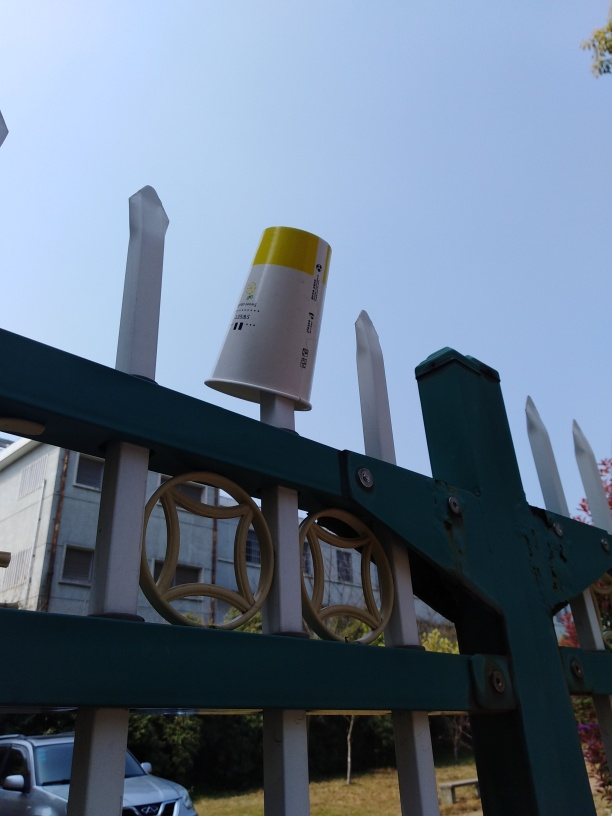Is there any loss of texture details in this image? The image appears to maintain a good level of texture detail overall. The different surfaces, such as the metal gate, the paper cup, and the foliage in the background, each show their distinct textures clearly. However, due to the specific lighting conditions and perspective, some subtle details, especially in the areas with less focus, might not be as sharp as they could be with optimal lighting or a different angle. 